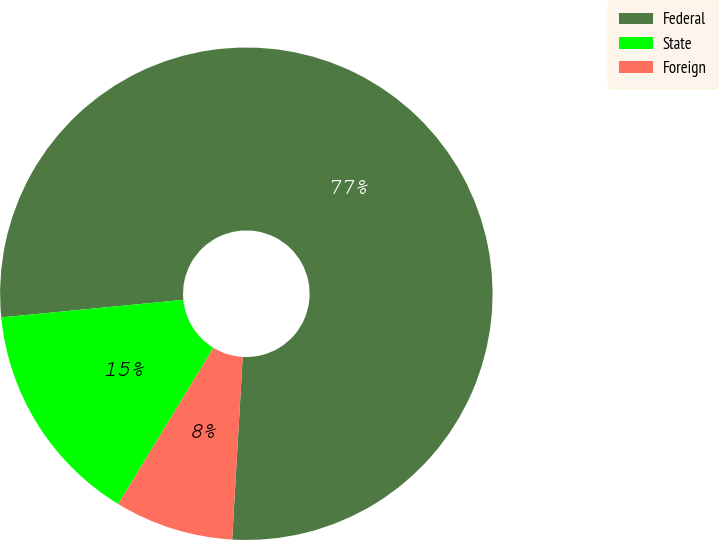Convert chart. <chart><loc_0><loc_0><loc_500><loc_500><pie_chart><fcel>Federal<fcel>State<fcel>Foreign<nl><fcel>77.45%<fcel>14.76%<fcel>7.79%<nl></chart> 